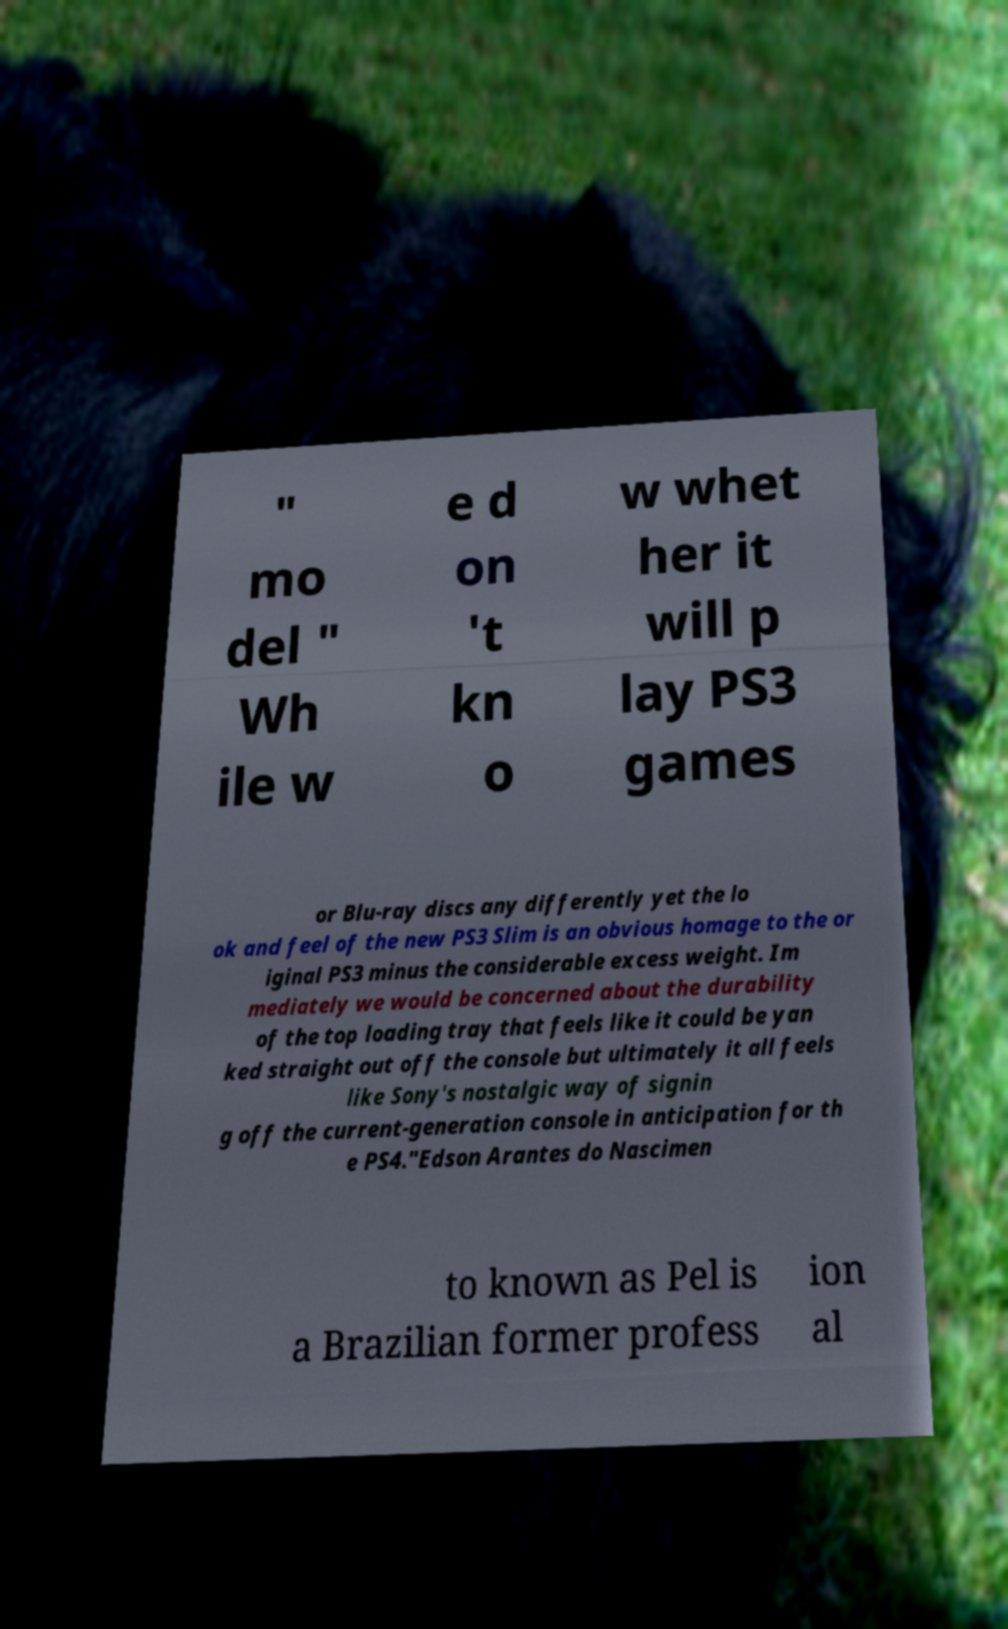Please read and relay the text visible in this image. What does it say? " mo del " Wh ile w e d on 't kn o w whet her it will p lay PS3 games or Blu-ray discs any differently yet the lo ok and feel of the new PS3 Slim is an obvious homage to the or iginal PS3 minus the considerable excess weight. Im mediately we would be concerned about the durability of the top loading tray that feels like it could be yan ked straight out off the console but ultimately it all feels like Sony's nostalgic way of signin g off the current-generation console in anticipation for th e PS4."Edson Arantes do Nascimen to known as Pel is a Brazilian former profess ion al 